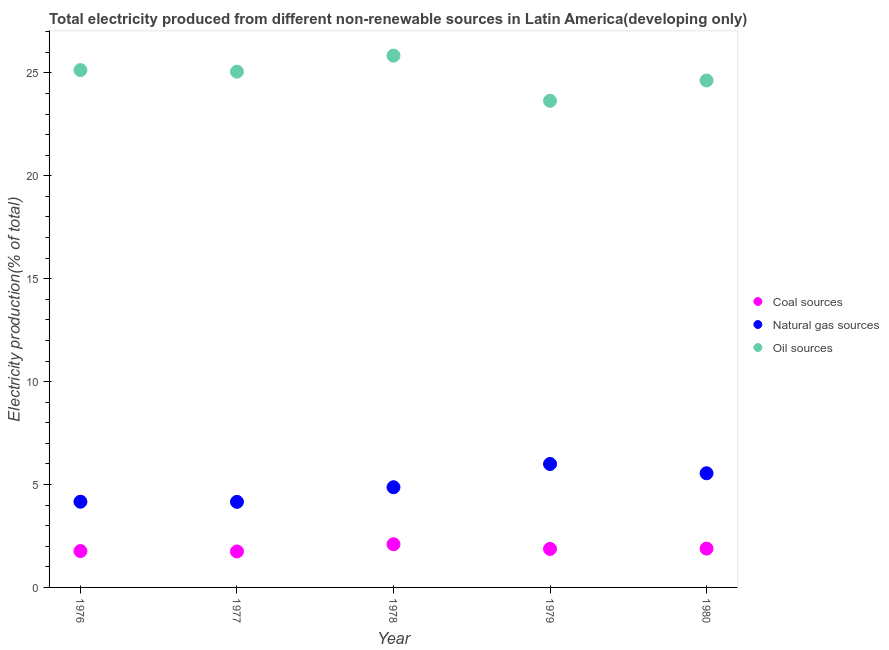How many different coloured dotlines are there?
Give a very brief answer. 3. What is the percentage of electricity produced by oil sources in 1979?
Give a very brief answer. 23.64. Across all years, what is the maximum percentage of electricity produced by oil sources?
Provide a succinct answer. 25.84. Across all years, what is the minimum percentage of electricity produced by natural gas?
Give a very brief answer. 4.16. In which year was the percentage of electricity produced by coal maximum?
Your answer should be compact. 1978. What is the total percentage of electricity produced by coal in the graph?
Offer a very short reply. 9.37. What is the difference between the percentage of electricity produced by coal in 1979 and that in 1980?
Keep it short and to the point. -0.02. What is the difference between the percentage of electricity produced by natural gas in 1979 and the percentage of electricity produced by oil sources in 1977?
Provide a short and direct response. -19.06. What is the average percentage of electricity produced by oil sources per year?
Offer a very short reply. 24.86. In the year 1977, what is the difference between the percentage of electricity produced by coal and percentage of electricity produced by natural gas?
Offer a terse response. -2.41. In how many years, is the percentage of electricity produced by natural gas greater than 8 %?
Your response must be concise. 0. What is the ratio of the percentage of electricity produced by natural gas in 1977 to that in 1980?
Provide a succinct answer. 0.75. Is the difference between the percentage of electricity produced by coal in 1979 and 1980 greater than the difference between the percentage of electricity produced by oil sources in 1979 and 1980?
Offer a terse response. Yes. What is the difference between the highest and the second highest percentage of electricity produced by oil sources?
Ensure brevity in your answer.  0.7. What is the difference between the highest and the lowest percentage of electricity produced by coal?
Offer a terse response. 0.35. Is the sum of the percentage of electricity produced by coal in 1976 and 1977 greater than the maximum percentage of electricity produced by oil sources across all years?
Offer a very short reply. No. How many dotlines are there?
Provide a succinct answer. 3. Where does the legend appear in the graph?
Provide a succinct answer. Center right. How many legend labels are there?
Your answer should be very brief. 3. How are the legend labels stacked?
Ensure brevity in your answer.  Vertical. What is the title of the graph?
Your answer should be compact. Total electricity produced from different non-renewable sources in Latin America(developing only). Does "Oil" appear as one of the legend labels in the graph?
Provide a succinct answer. No. What is the label or title of the X-axis?
Your answer should be very brief. Year. What is the label or title of the Y-axis?
Your answer should be very brief. Electricity production(% of total). What is the Electricity production(% of total) of Coal sources in 1976?
Offer a terse response. 1.77. What is the Electricity production(% of total) of Natural gas sources in 1976?
Give a very brief answer. 4.16. What is the Electricity production(% of total) in Oil sources in 1976?
Your answer should be very brief. 25.13. What is the Electricity production(% of total) of Coal sources in 1977?
Offer a very short reply. 1.75. What is the Electricity production(% of total) of Natural gas sources in 1977?
Your response must be concise. 4.16. What is the Electricity production(% of total) of Oil sources in 1977?
Offer a terse response. 25.06. What is the Electricity production(% of total) in Coal sources in 1978?
Your response must be concise. 2.1. What is the Electricity production(% of total) in Natural gas sources in 1978?
Provide a succinct answer. 4.87. What is the Electricity production(% of total) in Oil sources in 1978?
Keep it short and to the point. 25.84. What is the Electricity production(% of total) in Coal sources in 1979?
Provide a short and direct response. 1.87. What is the Electricity production(% of total) in Natural gas sources in 1979?
Your response must be concise. 6. What is the Electricity production(% of total) in Oil sources in 1979?
Make the answer very short. 23.64. What is the Electricity production(% of total) in Coal sources in 1980?
Give a very brief answer. 1.89. What is the Electricity production(% of total) in Natural gas sources in 1980?
Provide a short and direct response. 5.55. What is the Electricity production(% of total) in Oil sources in 1980?
Offer a very short reply. 24.63. Across all years, what is the maximum Electricity production(% of total) in Coal sources?
Your answer should be very brief. 2.1. Across all years, what is the maximum Electricity production(% of total) of Natural gas sources?
Offer a very short reply. 6. Across all years, what is the maximum Electricity production(% of total) in Oil sources?
Keep it short and to the point. 25.84. Across all years, what is the minimum Electricity production(% of total) in Coal sources?
Make the answer very short. 1.75. Across all years, what is the minimum Electricity production(% of total) of Natural gas sources?
Give a very brief answer. 4.16. Across all years, what is the minimum Electricity production(% of total) of Oil sources?
Keep it short and to the point. 23.64. What is the total Electricity production(% of total) of Coal sources in the graph?
Offer a terse response. 9.37. What is the total Electricity production(% of total) of Natural gas sources in the graph?
Ensure brevity in your answer.  24.73. What is the total Electricity production(% of total) in Oil sources in the graph?
Offer a very short reply. 124.3. What is the difference between the Electricity production(% of total) in Coal sources in 1976 and that in 1977?
Offer a very short reply. 0.02. What is the difference between the Electricity production(% of total) in Natural gas sources in 1976 and that in 1977?
Make the answer very short. 0.01. What is the difference between the Electricity production(% of total) of Oil sources in 1976 and that in 1977?
Make the answer very short. 0.08. What is the difference between the Electricity production(% of total) of Coal sources in 1976 and that in 1978?
Your response must be concise. -0.33. What is the difference between the Electricity production(% of total) in Natural gas sources in 1976 and that in 1978?
Ensure brevity in your answer.  -0.7. What is the difference between the Electricity production(% of total) of Oil sources in 1976 and that in 1978?
Offer a very short reply. -0.7. What is the difference between the Electricity production(% of total) of Coal sources in 1976 and that in 1979?
Provide a short and direct response. -0.1. What is the difference between the Electricity production(% of total) in Natural gas sources in 1976 and that in 1979?
Ensure brevity in your answer.  -1.83. What is the difference between the Electricity production(% of total) in Oil sources in 1976 and that in 1979?
Offer a terse response. 1.49. What is the difference between the Electricity production(% of total) in Coal sources in 1976 and that in 1980?
Offer a very short reply. -0.12. What is the difference between the Electricity production(% of total) of Natural gas sources in 1976 and that in 1980?
Provide a succinct answer. -1.38. What is the difference between the Electricity production(% of total) of Oil sources in 1976 and that in 1980?
Provide a short and direct response. 0.51. What is the difference between the Electricity production(% of total) in Coal sources in 1977 and that in 1978?
Make the answer very short. -0.35. What is the difference between the Electricity production(% of total) in Natural gas sources in 1977 and that in 1978?
Give a very brief answer. -0.71. What is the difference between the Electricity production(% of total) of Oil sources in 1977 and that in 1978?
Give a very brief answer. -0.78. What is the difference between the Electricity production(% of total) in Coal sources in 1977 and that in 1979?
Keep it short and to the point. -0.12. What is the difference between the Electricity production(% of total) in Natural gas sources in 1977 and that in 1979?
Ensure brevity in your answer.  -1.84. What is the difference between the Electricity production(% of total) in Oil sources in 1977 and that in 1979?
Your answer should be very brief. 1.41. What is the difference between the Electricity production(% of total) of Coal sources in 1977 and that in 1980?
Give a very brief answer. -0.14. What is the difference between the Electricity production(% of total) in Natural gas sources in 1977 and that in 1980?
Your response must be concise. -1.39. What is the difference between the Electricity production(% of total) of Oil sources in 1977 and that in 1980?
Your answer should be very brief. 0.43. What is the difference between the Electricity production(% of total) of Coal sources in 1978 and that in 1979?
Make the answer very short. 0.23. What is the difference between the Electricity production(% of total) in Natural gas sources in 1978 and that in 1979?
Your answer should be very brief. -1.13. What is the difference between the Electricity production(% of total) in Oil sources in 1978 and that in 1979?
Offer a terse response. 2.2. What is the difference between the Electricity production(% of total) of Coal sources in 1978 and that in 1980?
Provide a succinct answer. 0.21. What is the difference between the Electricity production(% of total) in Natural gas sources in 1978 and that in 1980?
Provide a short and direct response. -0.68. What is the difference between the Electricity production(% of total) in Oil sources in 1978 and that in 1980?
Your response must be concise. 1.21. What is the difference between the Electricity production(% of total) in Coal sources in 1979 and that in 1980?
Your answer should be compact. -0.02. What is the difference between the Electricity production(% of total) in Natural gas sources in 1979 and that in 1980?
Ensure brevity in your answer.  0.45. What is the difference between the Electricity production(% of total) of Oil sources in 1979 and that in 1980?
Give a very brief answer. -0.99. What is the difference between the Electricity production(% of total) in Coal sources in 1976 and the Electricity production(% of total) in Natural gas sources in 1977?
Your answer should be very brief. -2.39. What is the difference between the Electricity production(% of total) of Coal sources in 1976 and the Electricity production(% of total) of Oil sources in 1977?
Provide a short and direct response. -23.29. What is the difference between the Electricity production(% of total) in Natural gas sources in 1976 and the Electricity production(% of total) in Oil sources in 1977?
Your answer should be very brief. -20.89. What is the difference between the Electricity production(% of total) of Coal sources in 1976 and the Electricity production(% of total) of Natural gas sources in 1978?
Keep it short and to the point. -3.1. What is the difference between the Electricity production(% of total) in Coal sources in 1976 and the Electricity production(% of total) in Oil sources in 1978?
Give a very brief answer. -24.07. What is the difference between the Electricity production(% of total) in Natural gas sources in 1976 and the Electricity production(% of total) in Oil sources in 1978?
Your response must be concise. -21.67. What is the difference between the Electricity production(% of total) of Coal sources in 1976 and the Electricity production(% of total) of Natural gas sources in 1979?
Provide a succinct answer. -4.23. What is the difference between the Electricity production(% of total) of Coal sources in 1976 and the Electricity production(% of total) of Oil sources in 1979?
Offer a terse response. -21.88. What is the difference between the Electricity production(% of total) in Natural gas sources in 1976 and the Electricity production(% of total) in Oil sources in 1979?
Offer a very short reply. -19.48. What is the difference between the Electricity production(% of total) in Coal sources in 1976 and the Electricity production(% of total) in Natural gas sources in 1980?
Give a very brief answer. -3.78. What is the difference between the Electricity production(% of total) of Coal sources in 1976 and the Electricity production(% of total) of Oil sources in 1980?
Make the answer very short. -22.86. What is the difference between the Electricity production(% of total) in Natural gas sources in 1976 and the Electricity production(% of total) in Oil sources in 1980?
Make the answer very short. -20.47. What is the difference between the Electricity production(% of total) in Coal sources in 1977 and the Electricity production(% of total) in Natural gas sources in 1978?
Your response must be concise. -3.12. What is the difference between the Electricity production(% of total) in Coal sources in 1977 and the Electricity production(% of total) in Oil sources in 1978?
Your answer should be very brief. -24.09. What is the difference between the Electricity production(% of total) of Natural gas sources in 1977 and the Electricity production(% of total) of Oil sources in 1978?
Ensure brevity in your answer.  -21.68. What is the difference between the Electricity production(% of total) of Coal sources in 1977 and the Electricity production(% of total) of Natural gas sources in 1979?
Your response must be concise. -4.25. What is the difference between the Electricity production(% of total) in Coal sources in 1977 and the Electricity production(% of total) in Oil sources in 1979?
Keep it short and to the point. -21.89. What is the difference between the Electricity production(% of total) of Natural gas sources in 1977 and the Electricity production(% of total) of Oil sources in 1979?
Ensure brevity in your answer.  -19.48. What is the difference between the Electricity production(% of total) of Coal sources in 1977 and the Electricity production(% of total) of Natural gas sources in 1980?
Ensure brevity in your answer.  -3.8. What is the difference between the Electricity production(% of total) in Coal sources in 1977 and the Electricity production(% of total) in Oil sources in 1980?
Make the answer very short. -22.88. What is the difference between the Electricity production(% of total) in Natural gas sources in 1977 and the Electricity production(% of total) in Oil sources in 1980?
Ensure brevity in your answer.  -20.47. What is the difference between the Electricity production(% of total) of Coal sources in 1978 and the Electricity production(% of total) of Natural gas sources in 1979?
Your answer should be very brief. -3.9. What is the difference between the Electricity production(% of total) in Coal sources in 1978 and the Electricity production(% of total) in Oil sources in 1979?
Provide a succinct answer. -21.54. What is the difference between the Electricity production(% of total) of Natural gas sources in 1978 and the Electricity production(% of total) of Oil sources in 1979?
Make the answer very short. -18.77. What is the difference between the Electricity production(% of total) of Coal sources in 1978 and the Electricity production(% of total) of Natural gas sources in 1980?
Offer a terse response. -3.45. What is the difference between the Electricity production(% of total) in Coal sources in 1978 and the Electricity production(% of total) in Oil sources in 1980?
Provide a short and direct response. -22.53. What is the difference between the Electricity production(% of total) of Natural gas sources in 1978 and the Electricity production(% of total) of Oil sources in 1980?
Your answer should be very brief. -19.76. What is the difference between the Electricity production(% of total) in Coal sources in 1979 and the Electricity production(% of total) in Natural gas sources in 1980?
Your answer should be very brief. -3.68. What is the difference between the Electricity production(% of total) of Coal sources in 1979 and the Electricity production(% of total) of Oil sources in 1980?
Give a very brief answer. -22.76. What is the difference between the Electricity production(% of total) in Natural gas sources in 1979 and the Electricity production(% of total) in Oil sources in 1980?
Ensure brevity in your answer.  -18.63. What is the average Electricity production(% of total) in Coal sources per year?
Provide a succinct answer. 1.87. What is the average Electricity production(% of total) of Natural gas sources per year?
Your response must be concise. 4.95. What is the average Electricity production(% of total) in Oil sources per year?
Provide a short and direct response. 24.86. In the year 1976, what is the difference between the Electricity production(% of total) of Coal sources and Electricity production(% of total) of Natural gas sources?
Your answer should be compact. -2.4. In the year 1976, what is the difference between the Electricity production(% of total) of Coal sources and Electricity production(% of total) of Oil sources?
Ensure brevity in your answer.  -23.37. In the year 1976, what is the difference between the Electricity production(% of total) of Natural gas sources and Electricity production(% of total) of Oil sources?
Keep it short and to the point. -20.97. In the year 1977, what is the difference between the Electricity production(% of total) of Coal sources and Electricity production(% of total) of Natural gas sources?
Provide a short and direct response. -2.41. In the year 1977, what is the difference between the Electricity production(% of total) in Coal sources and Electricity production(% of total) in Oil sources?
Keep it short and to the point. -23.31. In the year 1977, what is the difference between the Electricity production(% of total) in Natural gas sources and Electricity production(% of total) in Oil sources?
Your answer should be compact. -20.9. In the year 1978, what is the difference between the Electricity production(% of total) of Coal sources and Electricity production(% of total) of Natural gas sources?
Ensure brevity in your answer.  -2.77. In the year 1978, what is the difference between the Electricity production(% of total) in Coal sources and Electricity production(% of total) in Oil sources?
Provide a short and direct response. -23.74. In the year 1978, what is the difference between the Electricity production(% of total) in Natural gas sources and Electricity production(% of total) in Oil sources?
Give a very brief answer. -20.97. In the year 1979, what is the difference between the Electricity production(% of total) of Coal sources and Electricity production(% of total) of Natural gas sources?
Make the answer very short. -4.13. In the year 1979, what is the difference between the Electricity production(% of total) in Coal sources and Electricity production(% of total) in Oil sources?
Offer a very short reply. -21.77. In the year 1979, what is the difference between the Electricity production(% of total) in Natural gas sources and Electricity production(% of total) in Oil sources?
Provide a short and direct response. -17.64. In the year 1980, what is the difference between the Electricity production(% of total) in Coal sources and Electricity production(% of total) in Natural gas sources?
Offer a very short reply. -3.66. In the year 1980, what is the difference between the Electricity production(% of total) of Coal sources and Electricity production(% of total) of Oil sources?
Provide a succinct answer. -22.74. In the year 1980, what is the difference between the Electricity production(% of total) in Natural gas sources and Electricity production(% of total) in Oil sources?
Keep it short and to the point. -19.08. What is the ratio of the Electricity production(% of total) of Coal sources in 1976 to that in 1977?
Your answer should be compact. 1.01. What is the ratio of the Electricity production(% of total) of Coal sources in 1976 to that in 1978?
Give a very brief answer. 0.84. What is the ratio of the Electricity production(% of total) of Natural gas sources in 1976 to that in 1978?
Your answer should be compact. 0.86. What is the ratio of the Electricity production(% of total) of Oil sources in 1976 to that in 1978?
Provide a short and direct response. 0.97. What is the ratio of the Electricity production(% of total) in Coal sources in 1976 to that in 1979?
Your answer should be very brief. 0.94. What is the ratio of the Electricity production(% of total) of Natural gas sources in 1976 to that in 1979?
Make the answer very short. 0.69. What is the ratio of the Electricity production(% of total) of Oil sources in 1976 to that in 1979?
Keep it short and to the point. 1.06. What is the ratio of the Electricity production(% of total) in Coal sources in 1976 to that in 1980?
Provide a succinct answer. 0.94. What is the ratio of the Electricity production(% of total) in Natural gas sources in 1976 to that in 1980?
Offer a terse response. 0.75. What is the ratio of the Electricity production(% of total) of Oil sources in 1976 to that in 1980?
Your answer should be compact. 1.02. What is the ratio of the Electricity production(% of total) of Coal sources in 1977 to that in 1978?
Ensure brevity in your answer.  0.83. What is the ratio of the Electricity production(% of total) of Natural gas sources in 1977 to that in 1978?
Make the answer very short. 0.85. What is the ratio of the Electricity production(% of total) in Oil sources in 1977 to that in 1978?
Your answer should be compact. 0.97. What is the ratio of the Electricity production(% of total) of Coal sources in 1977 to that in 1979?
Keep it short and to the point. 0.93. What is the ratio of the Electricity production(% of total) in Natural gas sources in 1977 to that in 1979?
Offer a terse response. 0.69. What is the ratio of the Electricity production(% of total) of Oil sources in 1977 to that in 1979?
Make the answer very short. 1.06. What is the ratio of the Electricity production(% of total) in Coal sources in 1977 to that in 1980?
Your answer should be compact. 0.93. What is the ratio of the Electricity production(% of total) in Natural gas sources in 1977 to that in 1980?
Offer a very short reply. 0.75. What is the ratio of the Electricity production(% of total) in Oil sources in 1977 to that in 1980?
Ensure brevity in your answer.  1.02. What is the ratio of the Electricity production(% of total) in Coal sources in 1978 to that in 1979?
Make the answer very short. 1.12. What is the ratio of the Electricity production(% of total) in Natural gas sources in 1978 to that in 1979?
Your answer should be very brief. 0.81. What is the ratio of the Electricity production(% of total) of Oil sources in 1978 to that in 1979?
Your response must be concise. 1.09. What is the ratio of the Electricity production(% of total) of Coal sources in 1978 to that in 1980?
Your answer should be very brief. 1.11. What is the ratio of the Electricity production(% of total) of Natural gas sources in 1978 to that in 1980?
Provide a succinct answer. 0.88. What is the ratio of the Electricity production(% of total) of Oil sources in 1978 to that in 1980?
Offer a terse response. 1.05. What is the ratio of the Electricity production(% of total) of Coal sources in 1979 to that in 1980?
Your answer should be very brief. 0.99. What is the ratio of the Electricity production(% of total) in Natural gas sources in 1979 to that in 1980?
Your answer should be compact. 1.08. What is the ratio of the Electricity production(% of total) in Oil sources in 1979 to that in 1980?
Offer a terse response. 0.96. What is the difference between the highest and the second highest Electricity production(% of total) in Coal sources?
Ensure brevity in your answer.  0.21. What is the difference between the highest and the second highest Electricity production(% of total) in Natural gas sources?
Your answer should be very brief. 0.45. What is the difference between the highest and the second highest Electricity production(% of total) of Oil sources?
Your response must be concise. 0.7. What is the difference between the highest and the lowest Electricity production(% of total) of Coal sources?
Make the answer very short. 0.35. What is the difference between the highest and the lowest Electricity production(% of total) of Natural gas sources?
Keep it short and to the point. 1.84. What is the difference between the highest and the lowest Electricity production(% of total) in Oil sources?
Make the answer very short. 2.2. 